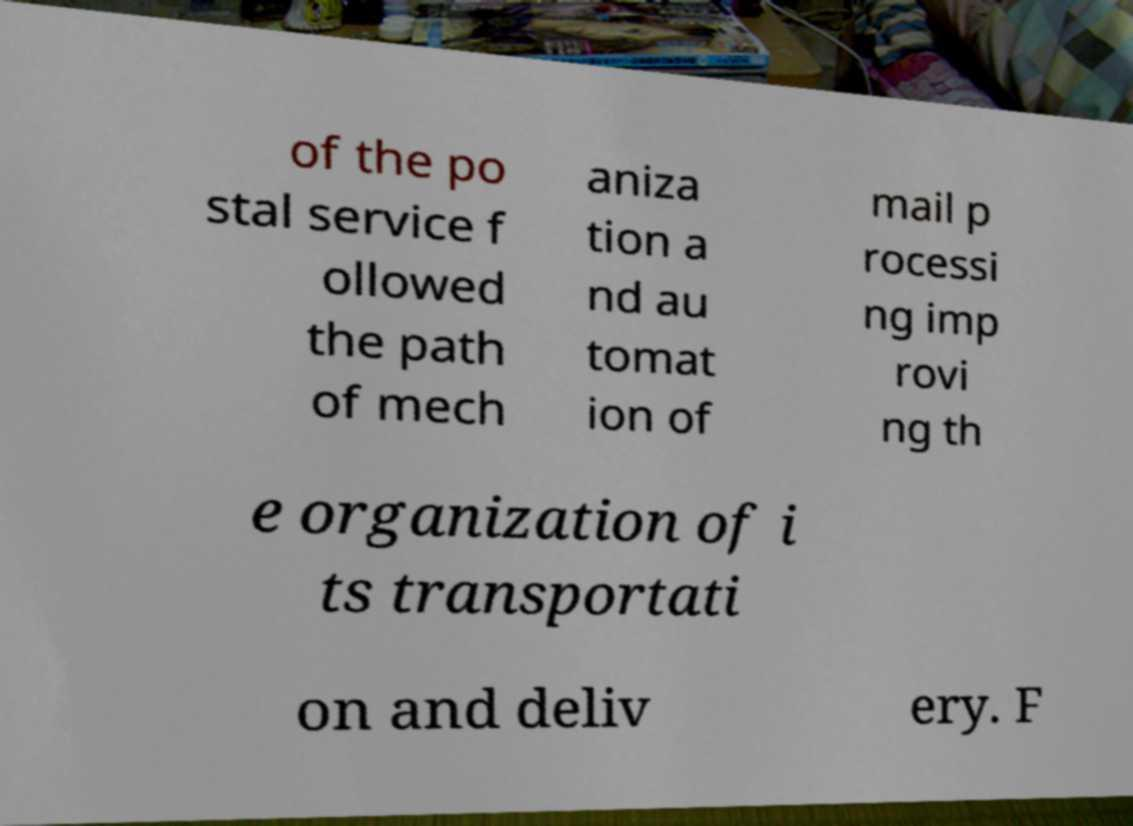For documentation purposes, I need the text within this image transcribed. Could you provide that? of the po stal service f ollowed the path of mech aniza tion a nd au tomat ion of mail p rocessi ng imp rovi ng th e organization of i ts transportati on and deliv ery. F 